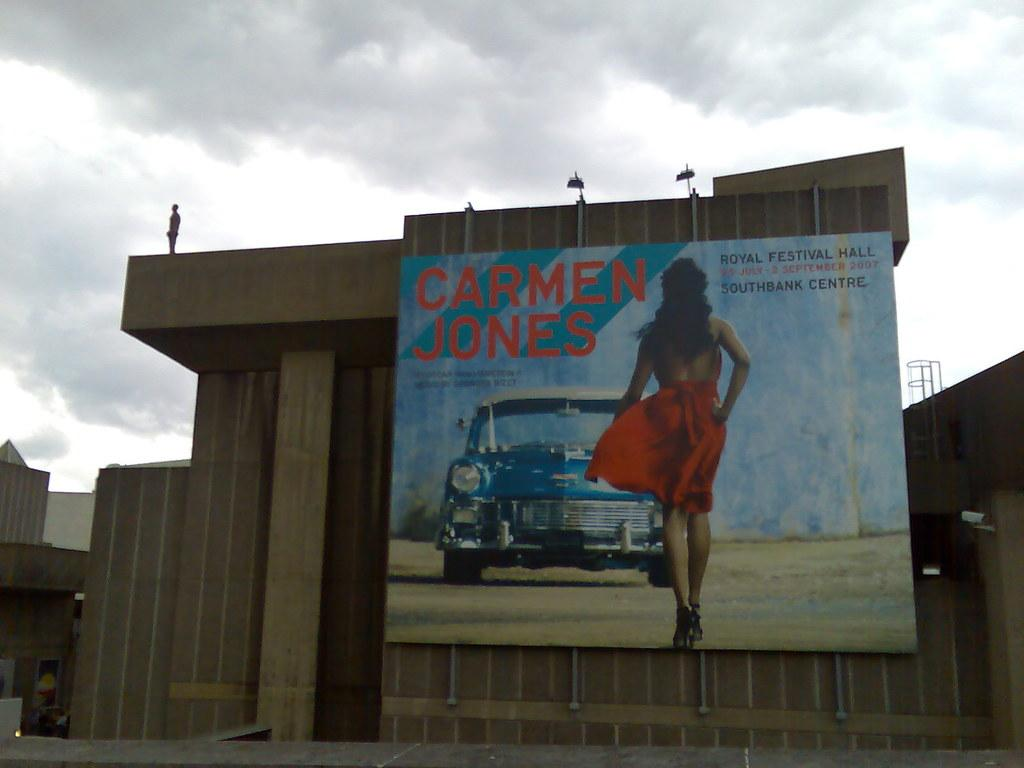<image>
Give a short and clear explanation of the subsequent image. An ad for Carmen Jones on an old wooden building. 